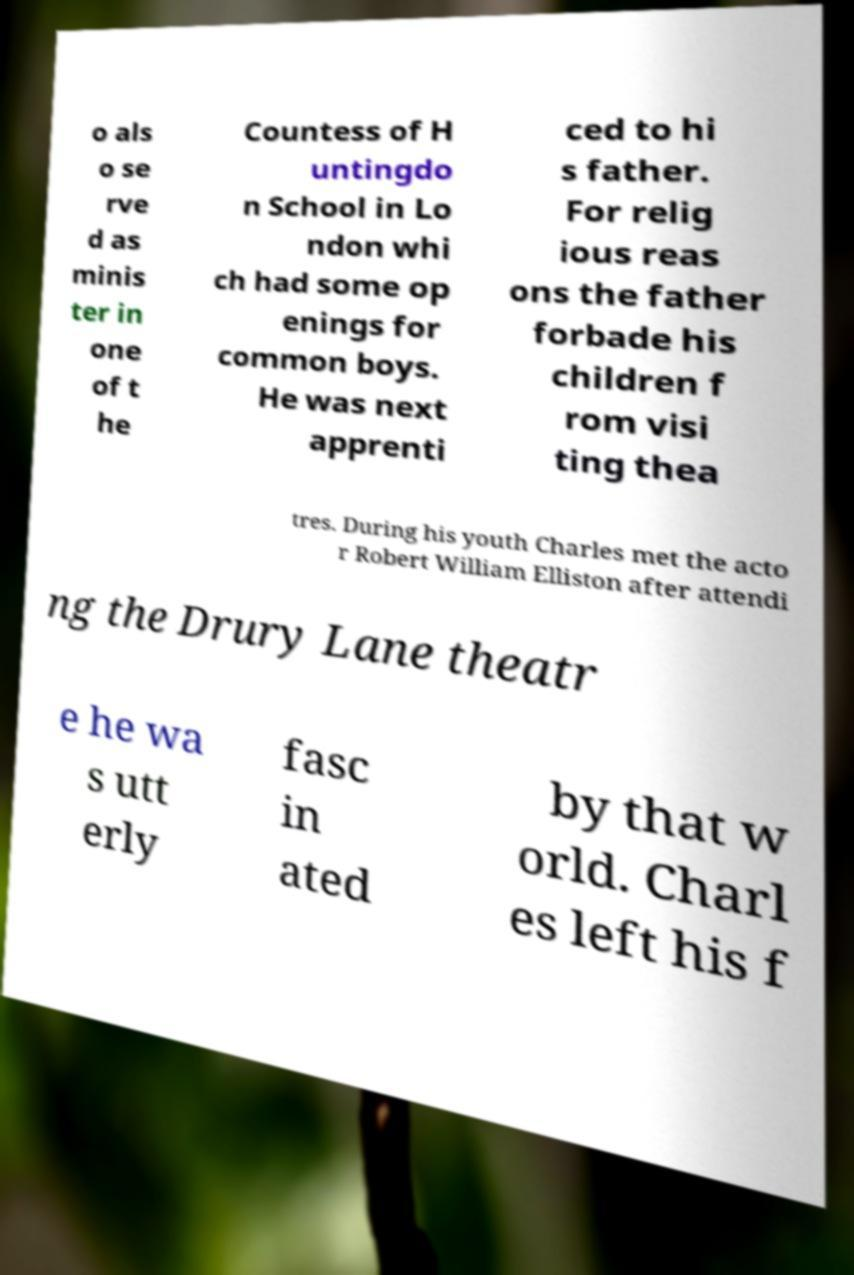Please identify and transcribe the text found in this image. o als o se rve d as minis ter in one of t he Countess of H untingdo n School in Lo ndon whi ch had some op enings for common boys. He was next apprenti ced to hi s father. For relig ious reas ons the father forbade his children f rom visi ting thea tres. During his youth Charles met the acto r Robert William Elliston after attendi ng the Drury Lane theatr e he wa s utt erly fasc in ated by that w orld. Charl es left his f 